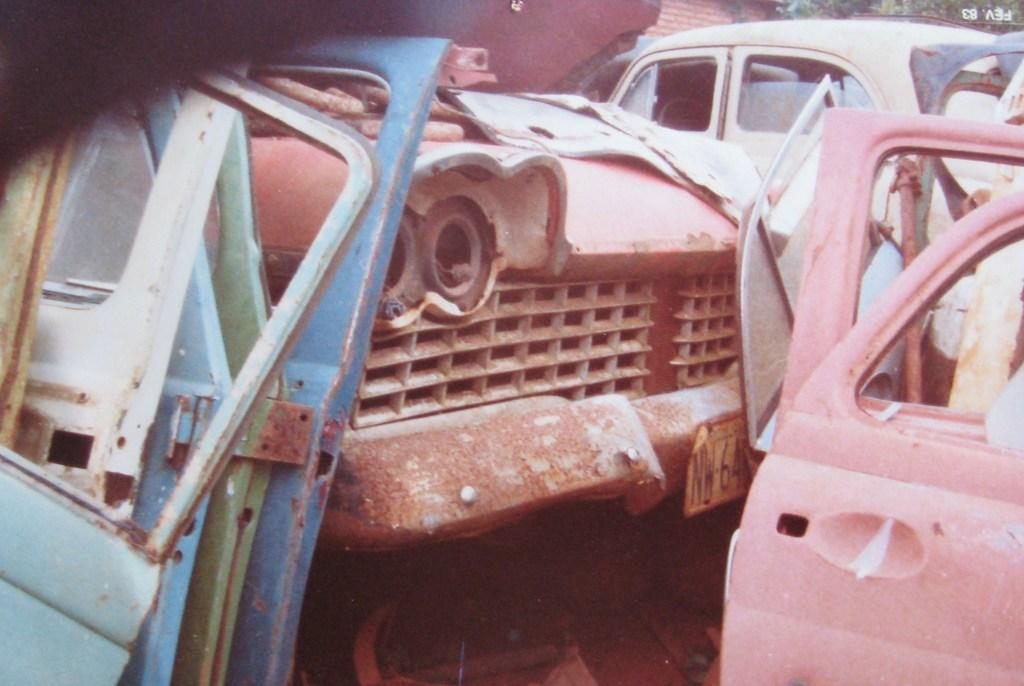What type of objects are present in the image? There are vehicles in the image. What specific features can be observed on the vehicles? The vehicles have number plates and doors. What can be seen in the background of the image? There is a wall and leaves visible in the background of the image. What type of teeth can be seen on the vehicles in the image? There are no teeth present on the vehicles in the image. How quiet is the environment in the image? The provided facts do not give any information about the noise level in the image, so it cannot be determined from the image. 